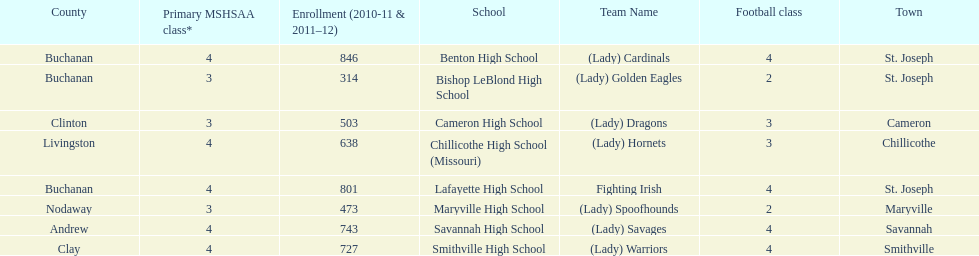Which schools are in the same town as bishop leblond? Benton High School, Lafayette High School. Write the full table. {'header': ['County', 'Primary MSHSAA class*', 'Enrollment (2010-11 & 2011–12)', 'School', 'Team Name', 'Football class', 'Town'], 'rows': [['Buchanan', '4', '846', 'Benton High School', '(Lady) Cardinals', '4', 'St. Joseph'], ['Buchanan', '3', '314', 'Bishop LeBlond High School', '(Lady) Golden Eagles', '2', 'St. Joseph'], ['Clinton', '3', '503', 'Cameron High School', '(Lady) Dragons', '3', 'Cameron'], ['Livingston', '4', '638', 'Chillicothe High School (Missouri)', '(Lady) Hornets', '3', 'Chillicothe'], ['Buchanan', '4', '801', 'Lafayette High School', 'Fighting Irish', '4', 'St. Joseph'], ['Nodaway', '3', '473', 'Maryville High School', '(Lady) Spoofhounds', '2', 'Maryville'], ['Andrew', '4', '743', 'Savannah High School', '(Lady) Savages', '4', 'Savannah'], ['Clay', '4', '727', 'Smithville High School', '(Lady) Warriors', '4', 'Smithville']]} 